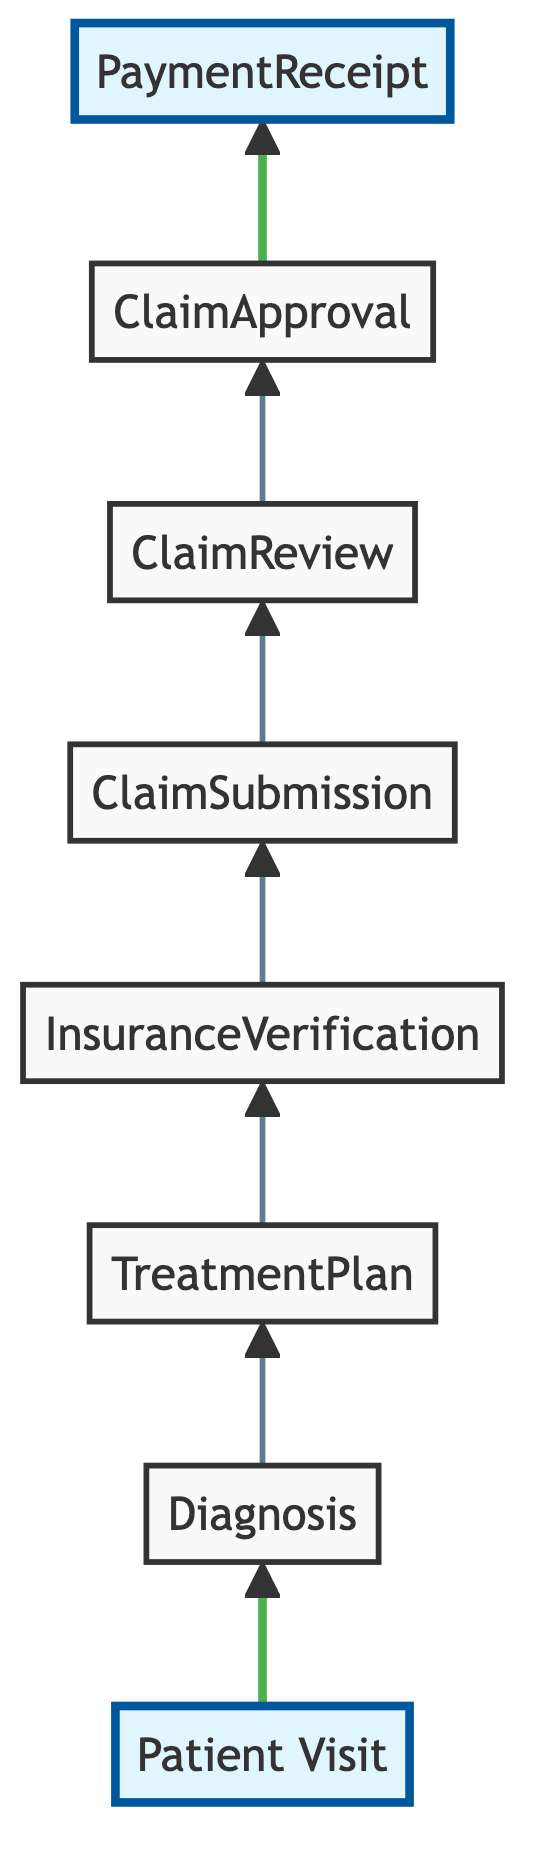What is the first step in the insurance claims submission workflow? The diagram begins with the node labeled "Patient Visit," indicating that this is the first step in the workflow.
Answer: Patient Visit How many nodes are in the diagram? By counting the individual elements listed, we find a total of eight nodes involved in the insurance claims submission workflow.
Answer: Eight What is the last step in the workflow? The final node shown in the flow is "Payment Receipt," which indicates the completion of the claim process.
Answer: Payment Receipt Which step follows "Claim Submission"? The diagram shows an arrow leading from "Claim Submission" to "Claim Review," indicating that this is the next step in the workflow after submitting a claim.
Answer: Claim Review What action is taken after "Claim Approval"? Following "Claim Approval," the diagram shows that "Payment Receipt" is the next action to occur, indicating that payment for services will be received.
Answer: Payment Receipt What is the primary focus of the workflow? The overall focus of the workflow is illustrated through the sequence of steps leading to successful claim processing and payment receipt, which emphasizes the claim submission journey.
Answer: Claim processing How does "Insurance Verification" relate to "Diagnosis"? "Insurance Verification" follows "Treatment Plan" in the progression, illustrating that insurance coverage is confirmed after a diagnosis and treatment plan have been established.
Answer: Follows Which step is highlighted at the beginning and the end of the workflow? The diagram highlights the "Patient Visit" at the beginning and "Payment Receipt" at the end, marking significant points of entry and exit in the workflow.
Answer: Patient Visit and Payment Receipt 